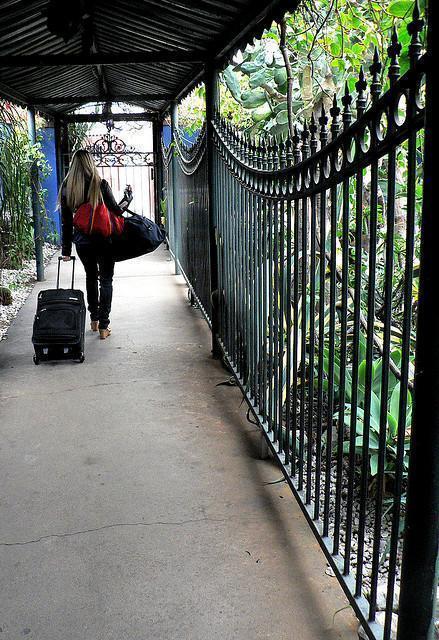Where is the woman likely heading?
Answer the question by selecting the correct answer among the 4 following choices and explain your choice with a short sentence. The answer should be formatted with the following format: `Answer: choice
Rationale: rationale.`
Options: Vacation, work, dinner, school. Answer: vacation.
Rationale: She has a suitcase so she probably is going on holiday 